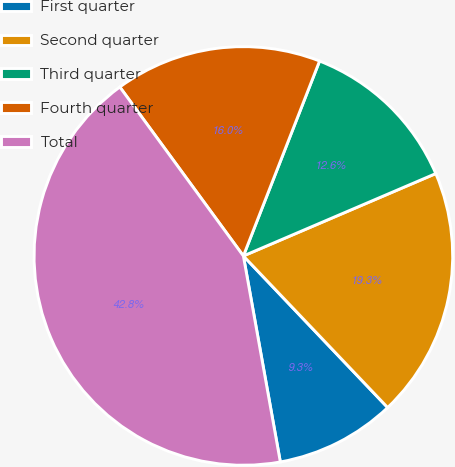<chart> <loc_0><loc_0><loc_500><loc_500><pie_chart><fcel>First quarter<fcel>Second quarter<fcel>Third quarter<fcel>Fourth quarter<fcel>Total<nl><fcel>9.28%<fcel>19.33%<fcel>12.63%<fcel>15.98%<fcel>42.77%<nl></chart> 